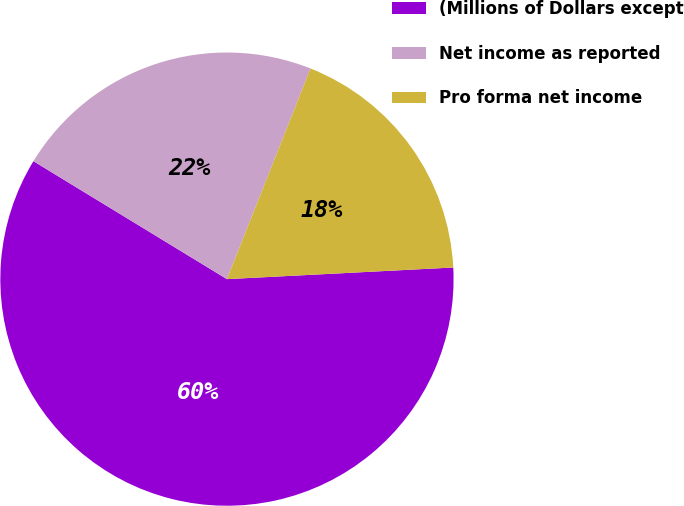Convert chart. <chart><loc_0><loc_0><loc_500><loc_500><pie_chart><fcel>(Millions of Dollars except<fcel>Net income as reported<fcel>Pro forma net income<nl><fcel>59.53%<fcel>22.3%<fcel>18.17%<nl></chart> 